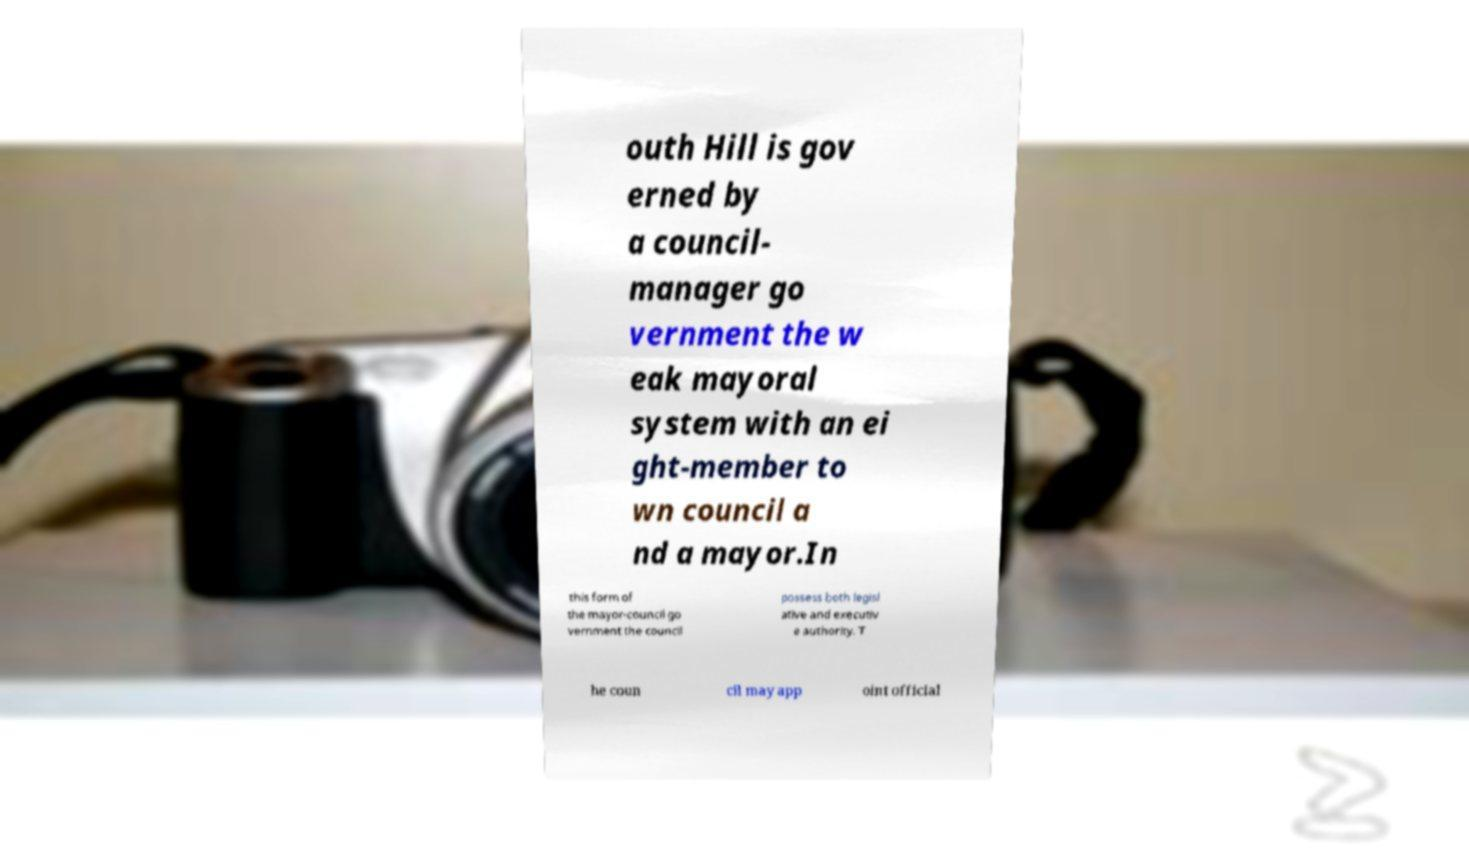For documentation purposes, I need the text within this image transcribed. Could you provide that? outh Hill is gov erned by a council- manager go vernment the w eak mayoral system with an ei ght-member to wn council a nd a mayor.In this form of the mayor-council go vernment the council possess both legisl ative and executiv e authority. T he coun cil may app oint official 